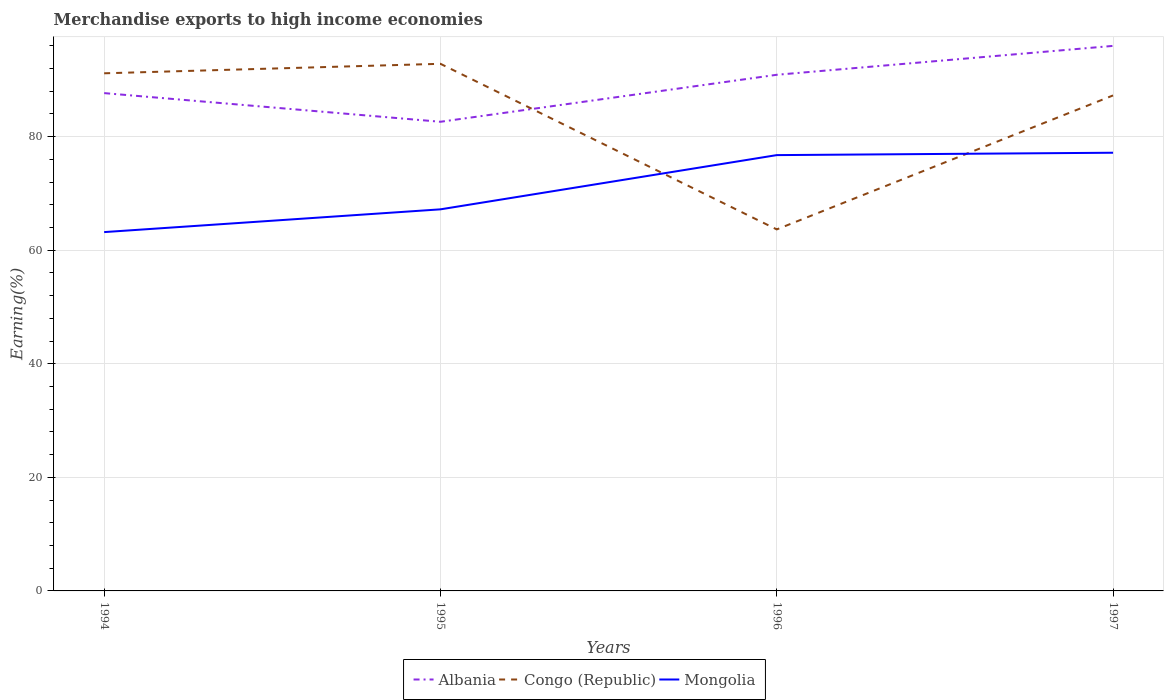Is the number of lines equal to the number of legend labels?
Provide a short and direct response. Yes. Across all years, what is the maximum percentage of amount earned from merchandise exports in Albania?
Keep it short and to the point. 82.61. What is the total percentage of amount earned from merchandise exports in Congo (Republic) in the graph?
Your response must be concise. -23.59. What is the difference between the highest and the second highest percentage of amount earned from merchandise exports in Mongolia?
Make the answer very short. 13.97. What is the difference between the highest and the lowest percentage of amount earned from merchandise exports in Mongolia?
Keep it short and to the point. 2. Is the percentage of amount earned from merchandise exports in Albania strictly greater than the percentage of amount earned from merchandise exports in Mongolia over the years?
Provide a short and direct response. No. How many lines are there?
Give a very brief answer. 3. Does the graph contain grids?
Provide a succinct answer. Yes. How many legend labels are there?
Your response must be concise. 3. How are the legend labels stacked?
Your answer should be very brief. Horizontal. What is the title of the graph?
Offer a very short reply. Merchandise exports to high income economies. Does "Curacao" appear as one of the legend labels in the graph?
Offer a terse response. No. What is the label or title of the X-axis?
Give a very brief answer. Years. What is the label or title of the Y-axis?
Offer a very short reply. Earning(%). What is the Earning(%) in Albania in 1994?
Your answer should be very brief. 87.66. What is the Earning(%) of Congo (Republic) in 1994?
Offer a very short reply. 91.15. What is the Earning(%) of Mongolia in 1994?
Provide a succinct answer. 63.18. What is the Earning(%) of Albania in 1995?
Give a very brief answer. 82.61. What is the Earning(%) of Congo (Republic) in 1995?
Give a very brief answer. 92.82. What is the Earning(%) in Mongolia in 1995?
Keep it short and to the point. 67.19. What is the Earning(%) of Albania in 1996?
Make the answer very short. 90.89. What is the Earning(%) in Congo (Republic) in 1996?
Keep it short and to the point. 63.66. What is the Earning(%) of Mongolia in 1996?
Your answer should be very brief. 76.74. What is the Earning(%) of Albania in 1997?
Provide a short and direct response. 95.97. What is the Earning(%) of Congo (Republic) in 1997?
Give a very brief answer. 87.25. What is the Earning(%) in Mongolia in 1997?
Offer a terse response. 77.16. Across all years, what is the maximum Earning(%) of Albania?
Offer a very short reply. 95.97. Across all years, what is the maximum Earning(%) in Congo (Republic)?
Provide a short and direct response. 92.82. Across all years, what is the maximum Earning(%) of Mongolia?
Your response must be concise. 77.16. Across all years, what is the minimum Earning(%) in Albania?
Provide a short and direct response. 82.61. Across all years, what is the minimum Earning(%) in Congo (Republic)?
Keep it short and to the point. 63.66. Across all years, what is the minimum Earning(%) in Mongolia?
Ensure brevity in your answer.  63.18. What is the total Earning(%) of Albania in the graph?
Your response must be concise. 357.13. What is the total Earning(%) in Congo (Republic) in the graph?
Your response must be concise. 334.87. What is the total Earning(%) in Mongolia in the graph?
Provide a succinct answer. 284.27. What is the difference between the Earning(%) of Albania in 1994 and that in 1995?
Your answer should be compact. 5.05. What is the difference between the Earning(%) in Congo (Republic) in 1994 and that in 1995?
Your answer should be very brief. -1.67. What is the difference between the Earning(%) of Mongolia in 1994 and that in 1995?
Provide a short and direct response. -4.01. What is the difference between the Earning(%) in Albania in 1994 and that in 1996?
Keep it short and to the point. -3.23. What is the difference between the Earning(%) of Congo (Republic) in 1994 and that in 1996?
Make the answer very short. 27.49. What is the difference between the Earning(%) of Mongolia in 1994 and that in 1996?
Your answer should be compact. -13.56. What is the difference between the Earning(%) of Albania in 1994 and that in 1997?
Provide a succinct answer. -8.32. What is the difference between the Earning(%) in Congo (Republic) in 1994 and that in 1997?
Make the answer very short. 3.9. What is the difference between the Earning(%) in Mongolia in 1994 and that in 1997?
Provide a succinct answer. -13.97. What is the difference between the Earning(%) of Albania in 1995 and that in 1996?
Your response must be concise. -8.27. What is the difference between the Earning(%) in Congo (Republic) in 1995 and that in 1996?
Offer a very short reply. 29.16. What is the difference between the Earning(%) in Mongolia in 1995 and that in 1996?
Keep it short and to the point. -9.55. What is the difference between the Earning(%) in Albania in 1995 and that in 1997?
Offer a very short reply. -13.36. What is the difference between the Earning(%) of Congo (Republic) in 1995 and that in 1997?
Your answer should be very brief. 5.57. What is the difference between the Earning(%) in Mongolia in 1995 and that in 1997?
Keep it short and to the point. -9.97. What is the difference between the Earning(%) of Albania in 1996 and that in 1997?
Your answer should be very brief. -5.09. What is the difference between the Earning(%) of Congo (Republic) in 1996 and that in 1997?
Provide a succinct answer. -23.59. What is the difference between the Earning(%) of Mongolia in 1996 and that in 1997?
Ensure brevity in your answer.  -0.42. What is the difference between the Earning(%) in Albania in 1994 and the Earning(%) in Congo (Republic) in 1995?
Your response must be concise. -5.16. What is the difference between the Earning(%) of Albania in 1994 and the Earning(%) of Mongolia in 1995?
Your answer should be compact. 20.47. What is the difference between the Earning(%) of Congo (Republic) in 1994 and the Earning(%) of Mongolia in 1995?
Your answer should be very brief. 23.95. What is the difference between the Earning(%) in Albania in 1994 and the Earning(%) in Congo (Republic) in 1996?
Your response must be concise. 24. What is the difference between the Earning(%) of Albania in 1994 and the Earning(%) of Mongolia in 1996?
Your answer should be very brief. 10.92. What is the difference between the Earning(%) of Congo (Republic) in 1994 and the Earning(%) of Mongolia in 1996?
Keep it short and to the point. 14.41. What is the difference between the Earning(%) of Albania in 1994 and the Earning(%) of Congo (Republic) in 1997?
Offer a very short reply. 0.41. What is the difference between the Earning(%) of Albania in 1994 and the Earning(%) of Mongolia in 1997?
Make the answer very short. 10.5. What is the difference between the Earning(%) in Congo (Republic) in 1994 and the Earning(%) in Mongolia in 1997?
Your answer should be compact. 13.99. What is the difference between the Earning(%) of Albania in 1995 and the Earning(%) of Congo (Republic) in 1996?
Offer a terse response. 18.95. What is the difference between the Earning(%) of Albania in 1995 and the Earning(%) of Mongolia in 1996?
Your answer should be very brief. 5.87. What is the difference between the Earning(%) of Congo (Republic) in 1995 and the Earning(%) of Mongolia in 1996?
Provide a short and direct response. 16.08. What is the difference between the Earning(%) in Albania in 1995 and the Earning(%) in Congo (Republic) in 1997?
Give a very brief answer. -4.64. What is the difference between the Earning(%) of Albania in 1995 and the Earning(%) of Mongolia in 1997?
Give a very brief answer. 5.45. What is the difference between the Earning(%) in Congo (Republic) in 1995 and the Earning(%) in Mongolia in 1997?
Your response must be concise. 15.66. What is the difference between the Earning(%) of Albania in 1996 and the Earning(%) of Congo (Republic) in 1997?
Provide a succinct answer. 3.64. What is the difference between the Earning(%) of Albania in 1996 and the Earning(%) of Mongolia in 1997?
Your answer should be compact. 13.73. What is the average Earning(%) of Albania per year?
Offer a very short reply. 89.28. What is the average Earning(%) in Congo (Republic) per year?
Your answer should be very brief. 83.72. What is the average Earning(%) of Mongolia per year?
Make the answer very short. 71.07. In the year 1994, what is the difference between the Earning(%) of Albania and Earning(%) of Congo (Republic)?
Keep it short and to the point. -3.49. In the year 1994, what is the difference between the Earning(%) of Albania and Earning(%) of Mongolia?
Provide a short and direct response. 24.47. In the year 1994, what is the difference between the Earning(%) of Congo (Republic) and Earning(%) of Mongolia?
Your answer should be very brief. 27.96. In the year 1995, what is the difference between the Earning(%) in Albania and Earning(%) in Congo (Republic)?
Ensure brevity in your answer.  -10.21. In the year 1995, what is the difference between the Earning(%) of Albania and Earning(%) of Mongolia?
Offer a terse response. 15.42. In the year 1995, what is the difference between the Earning(%) in Congo (Republic) and Earning(%) in Mongolia?
Provide a succinct answer. 25.63. In the year 1996, what is the difference between the Earning(%) of Albania and Earning(%) of Congo (Republic)?
Offer a very short reply. 27.23. In the year 1996, what is the difference between the Earning(%) of Albania and Earning(%) of Mongolia?
Give a very brief answer. 14.15. In the year 1996, what is the difference between the Earning(%) of Congo (Republic) and Earning(%) of Mongolia?
Offer a very short reply. -13.08. In the year 1997, what is the difference between the Earning(%) of Albania and Earning(%) of Congo (Republic)?
Offer a terse response. 8.72. In the year 1997, what is the difference between the Earning(%) of Albania and Earning(%) of Mongolia?
Ensure brevity in your answer.  18.82. In the year 1997, what is the difference between the Earning(%) of Congo (Republic) and Earning(%) of Mongolia?
Offer a terse response. 10.09. What is the ratio of the Earning(%) in Albania in 1994 to that in 1995?
Make the answer very short. 1.06. What is the ratio of the Earning(%) of Congo (Republic) in 1994 to that in 1995?
Offer a very short reply. 0.98. What is the ratio of the Earning(%) of Mongolia in 1994 to that in 1995?
Your response must be concise. 0.94. What is the ratio of the Earning(%) of Albania in 1994 to that in 1996?
Give a very brief answer. 0.96. What is the ratio of the Earning(%) of Congo (Republic) in 1994 to that in 1996?
Give a very brief answer. 1.43. What is the ratio of the Earning(%) of Mongolia in 1994 to that in 1996?
Make the answer very short. 0.82. What is the ratio of the Earning(%) of Albania in 1994 to that in 1997?
Keep it short and to the point. 0.91. What is the ratio of the Earning(%) in Congo (Republic) in 1994 to that in 1997?
Keep it short and to the point. 1.04. What is the ratio of the Earning(%) of Mongolia in 1994 to that in 1997?
Your answer should be very brief. 0.82. What is the ratio of the Earning(%) of Albania in 1995 to that in 1996?
Provide a succinct answer. 0.91. What is the ratio of the Earning(%) in Congo (Republic) in 1995 to that in 1996?
Provide a succinct answer. 1.46. What is the ratio of the Earning(%) in Mongolia in 1995 to that in 1996?
Offer a very short reply. 0.88. What is the ratio of the Earning(%) of Albania in 1995 to that in 1997?
Keep it short and to the point. 0.86. What is the ratio of the Earning(%) in Congo (Republic) in 1995 to that in 1997?
Offer a terse response. 1.06. What is the ratio of the Earning(%) of Mongolia in 1995 to that in 1997?
Provide a short and direct response. 0.87. What is the ratio of the Earning(%) in Albania in 1996 to that in 1997?
Provide a short and direct response. 0.95. What is the ratio of the Earning(%) of Congo (Republic) in 1996 to that in 1997?
Provide a succinct answer. 0.73. What is the ratio of the Earning(%) in Mongolia in 1996 to that in 1997?
Give a very brief answer. 0.99. What is the difference between the highest and the second highest Earning(%) in Albania?
Ensure brevity in your answer.  5.09. What is the difference between the highest and the second highest Earning(%) of Congo (Republic)?
Provide a short and direct response. 1.67. What is the difference between the highest and the second highest Earning(%) of Mongolia?
Your answer should be very brief. 0.42. What is the difference between the highest and the lowest Earning(%) of Albania?
Your response must be concise. 13.36. What is the difference between the highest and the lowest Earning(%) in Congo (Republic)?
Offer a very short reply. 29.16. What is the difference between the highest and the lowest Earning(%) in Mongolia?
Provide a succinct answer. 13.97. 